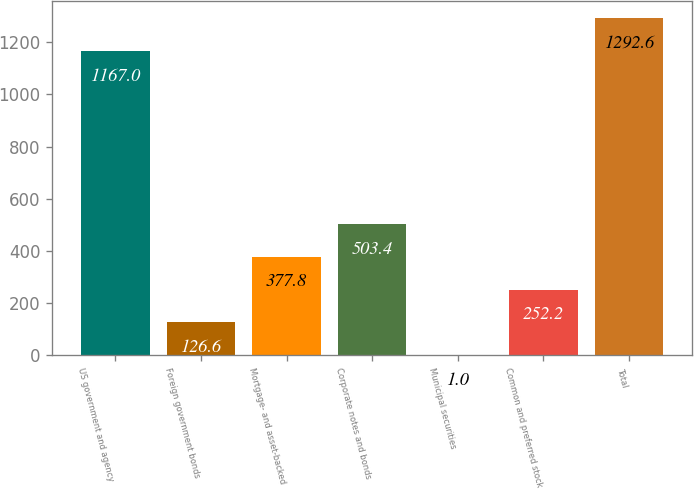<chart> <loc_0><loc_0><loc_500><loc_500><bar_chart><fcel>US government and agency<fcel>Foreign government bonds<fcel>Mortgage- and asset-backed<fcel>Corporate notes and bonds<fcel>Municipal securities<fcel>Common and preferred stock<fcel>Total<nl><fcel>1167<fcel>126.6<fcel>377.8<fcel>503.4<fcel>1<fcel>252.2<fcel>1292.6<nl></chart> 